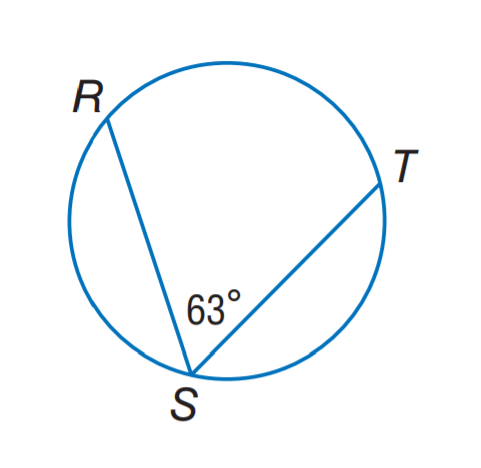Question: Find m \widehat R T.
Choices:
A. 54
B. 63
C. 108
D. 126
Answer with the letter. Answer: D 